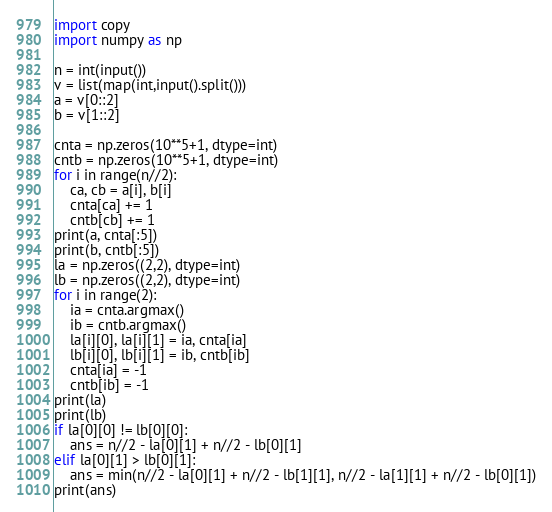Convert code to text. <code><loc_0><loc_0><loc_500><loc_500><_Python_>import copy
import numpy as np

n = int(input())
v = list(map(int,input().split()))
a = v[0::2] 
b = v[1::2]

cnta = np.zeros(10**5+1, dtype=int)
cntb = np.zeros(10**5+1, dtype=int)
for i in range(n//2):
    ca, cb = a[i], b[i]
    cnta[ca] += 1
    cntb[cb] += 1
print(a, cnta[:5])
print(b, cntb[:5])
la = np.zeros((2,2), dtype=int)
lb = np.zeros((2,2), dtype=int)
for i in range(2):
    ia = cnta.argmax()
    ib = cntb.argmax()
    la[i][0], la[i][1] = ia, cnta[ia]
    lb[i][0], lb[i][1] = ib, cntb[ib]
    cnta[ia] = -1
    cntb[ib] = -1
print(la)
print(lb)
if la[0][0] != lb[0][0]:
    ans = n//2 - la[0][1] + n//2 - lb[0][1]
elif la[0][1] > lb[0][1]:
    ans = min(n//2 - la[0][1] + n//2 - lb[1][1], n//2 - la[1][1] + n//2 - lb[0][1])
print(ans)</code> 